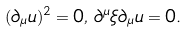<formula> <loc_0><loc_0><loc_500><loc_500>( \partial _ { \mu } u ) ^ { 2 } = 0 , \, \partial ^ { \mu } \xi \partial _ { \mu } u = 0 .</formula> 